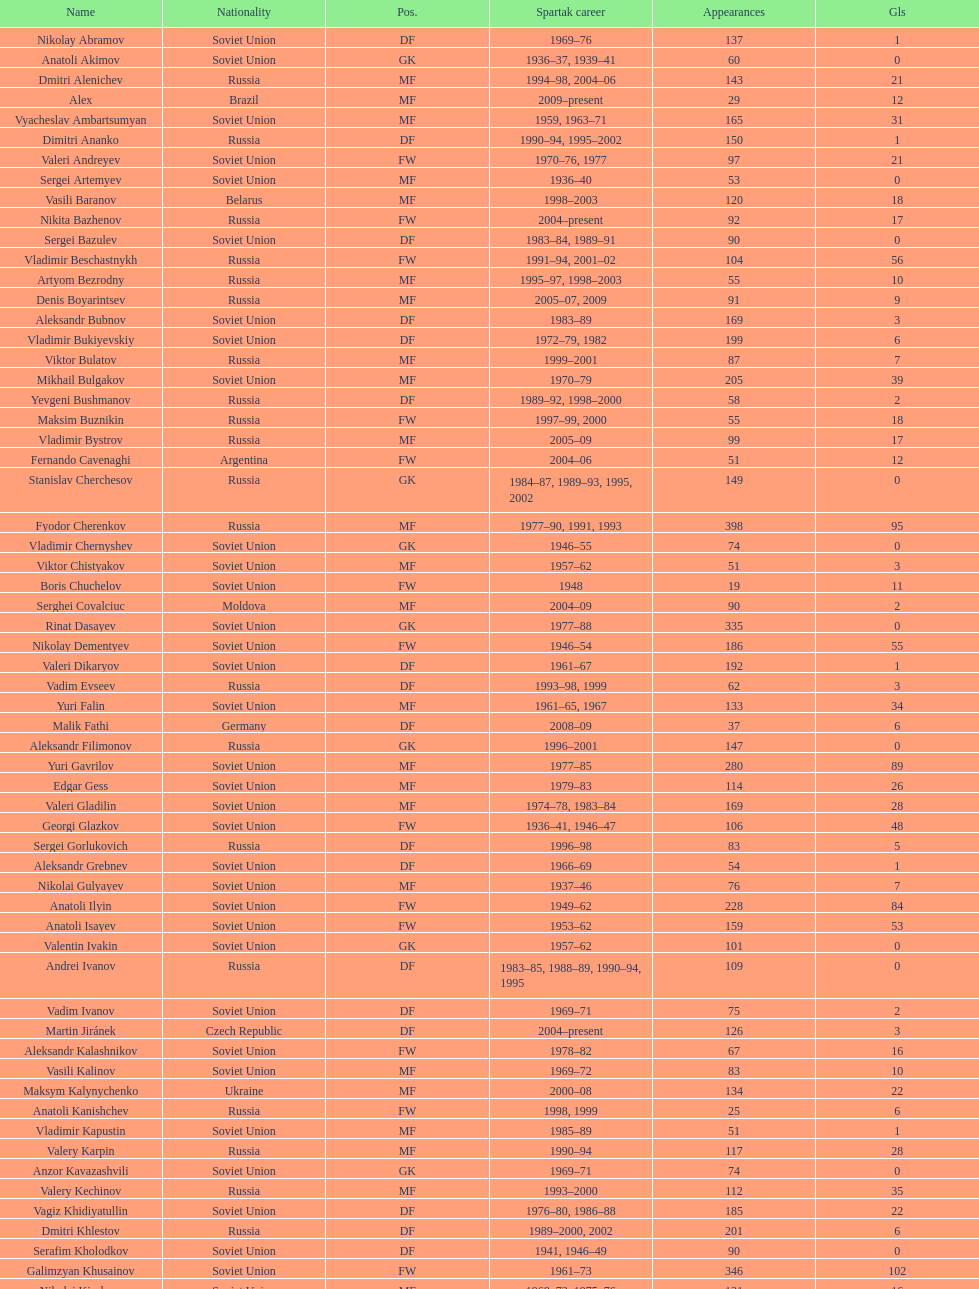How many players had at least 20 league goals scored? 56. 